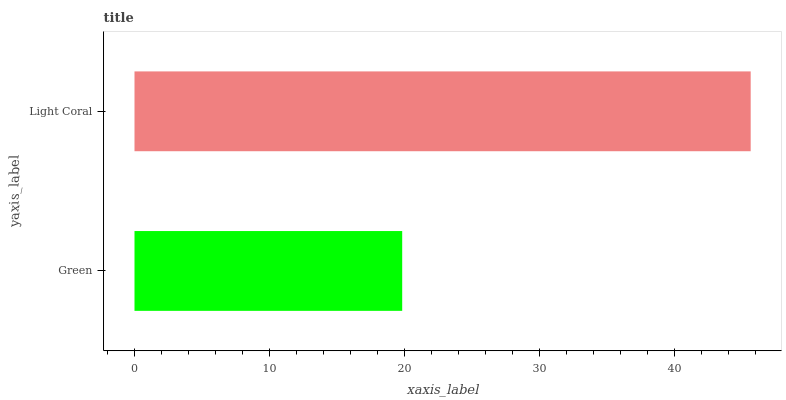Is Green the minimum?
Answer yes or no. Yes. Is Light Coral the maximum?
Answer yes or no. Yes. Is Light Coral the minimum?
Answer yes or no. No. Is Light Coral greater than Green?
Answer yes or no. Yes. Is Green less than Light Coral?
Answer yes or no. Yes. Is Green greater than Light Coral?
Answer yes or no. No. Is Light Coral less than Green?
Answer yes or no. No. Is Light Coral the high median?
Answer yes or no. Yes. Is Green the low median?
Answer yes or no. Yes. Is Green the high median?
Answer yes or no. No. Is Light Coral the low median?
Answer yes or no. No. 